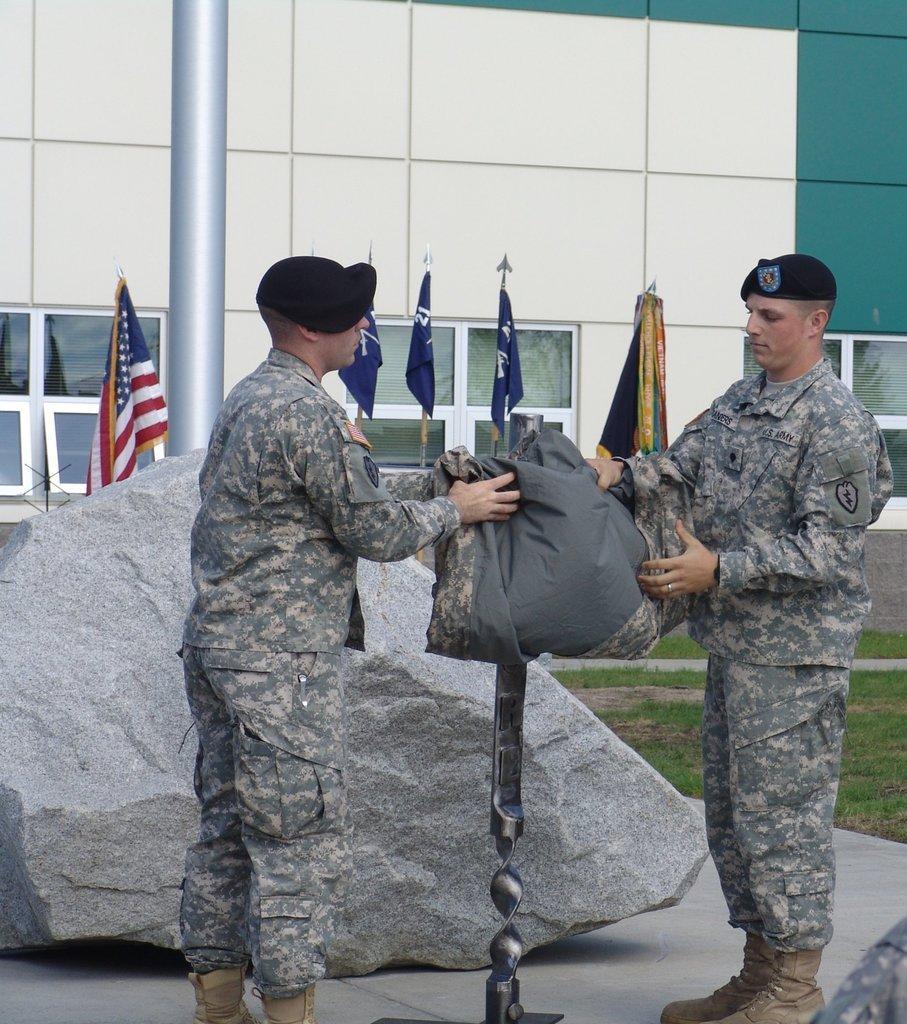Could you give a brief overview of what you see in this image? In this image we can see two military persons holding an object beside to them there is rock, also we can see building, pole, flags, windows, and a garden. 